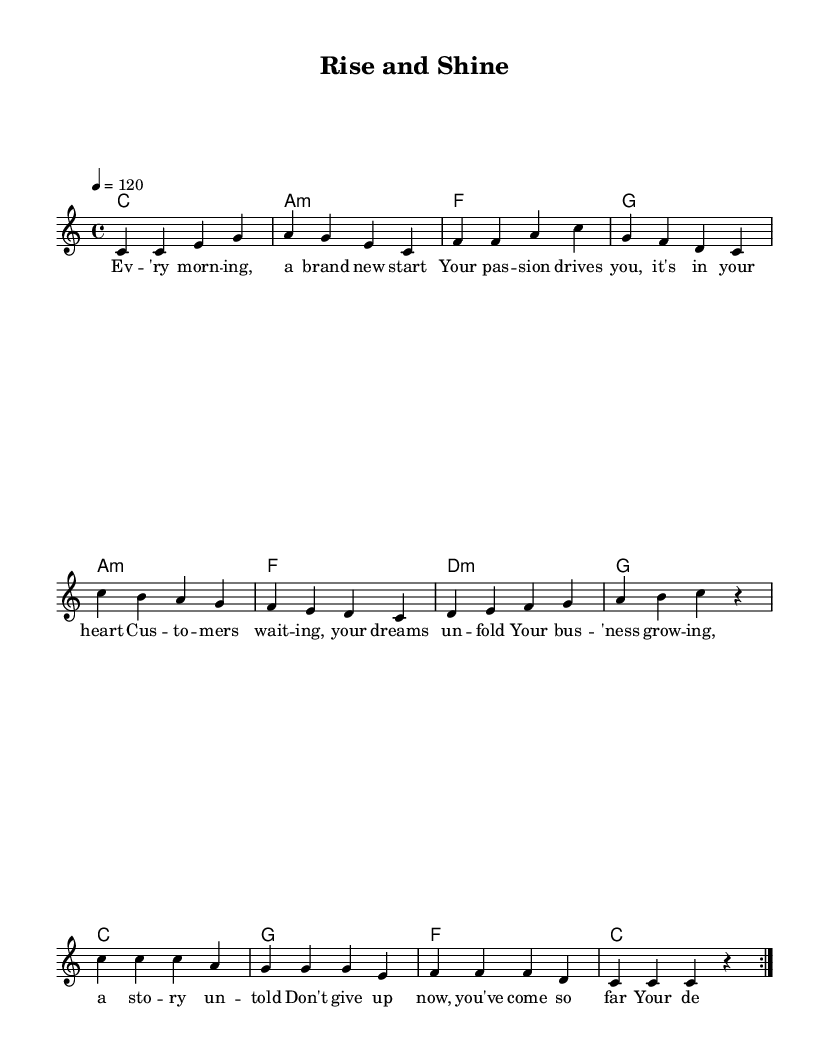What is the key signature of this music? The key signature is indicated at the beginning of the music. Here, it shows no sharps or flats, which corresponds to C major.
Answer: C major What is the time signature of this music? The time signature can be found at the beginning of the sheet music. It is indicated as 4/4, which means there are four beats in each measure, and the quarter note gets one beat.
Answer: 4/4 What is the tempo marking for this piece? The tempo marking is indicated in beats per minute (BPM) at the beginning of the score. It shows '4 = 120', meaning there are 120 quarter note beats per minute.
Answer: 120 How many measures are in the melody section? The melody section has several bars, and counting each segment separated by vertical lines in the music, there are 16 measures in total.
Answer: 16 What is the first lyric line in this piece? The first line of lyrics can be found under the melody section. It reads, "Ev'ry morn-ing, a brand new start".
Answer: Ev'ry morn-ing, a brand new start What type of chord progression is primarily used in the harmony section? By examining the chord symbols below the staff, the harmony primarily uses common pop chord progressions, including a mix of major and minor chords. The progression follows a C, Am, F, G pattern commonly used in pop music.
Answer: C, Am, F, G 